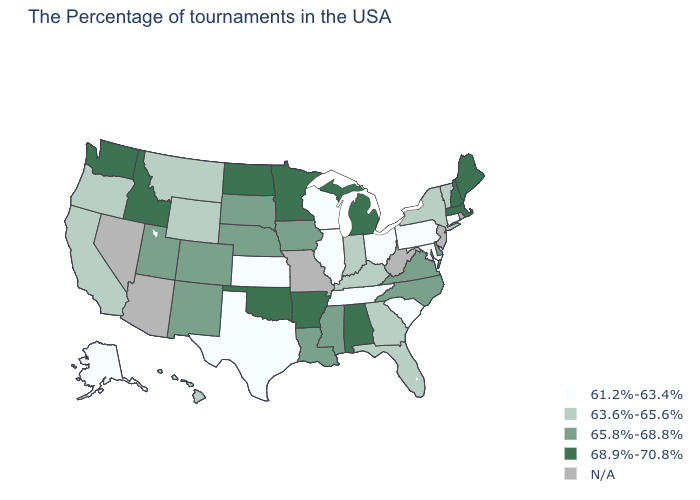Which states have the lowest value in the USA?
Write a very short answer. Connecticut, Maryland, Pennsylvania, South Carolina, Ohio, Tennessee, Wisconsin, Illinois, Kansas, Texas, Alaska. Does the map have missing data?
Concise answer only. Yes. Is the legend a continuous bar?
Write a very short answer. No. What is the lowest value in states that border Rhode Island?
Be succinct. 61.2%-63.4%. Name the states that have a value in the range 65.8%-68.8%?
Keep it brief. Delaware, Virginia, North Carolina, Mississippi, Louisiana, Iowa, Nebraska, South Dakota, Colorado, New Mexico, Utah. Does the map have missing data?
Concise answer only. Yes. Name the states that have a value in the range 61.2%-63.4%?
Give a very brief answer. Connecticut, Maryland, Pennsylvania, South Carolina, Ohio, Tennessee, Wisconsin, Illinois, Kansas, Texas, Alaska. What is the highest value in the West ?
Answer briefly. 68.9%-70.8%. What is the lowest value in states that border Nebraska?
Keep it brief. 61.2%-63.4%. Does Vermont have the highest value in the USA?
Concise answer only. No. Does Massachusetts have the lowest value in the Northeast?
Short answer required. No. What is the value of Utah?
Quick response, please. 65.8%-68.8%. Name the states that have a value in the range N/A?
Short answer required. Rhode Island, New Jersey, West Virginia, Missouri, Arizona, Nevada. 